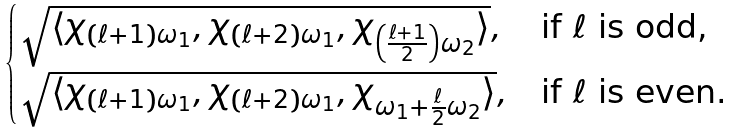<formula> <loc_0><loc_0><loc_500><loc_500>\begin{cases} \sqrt { \langle \chi _ { ( \ell + 1 ) \omega _ { 1 } } , \chi _ { ( \ell + 2 ) \omega _ { 1 } } , \chi _ { \left ( \frac { \ell + 1 } { 2 } \right ) \omega _ { 2 } } \rangle } , & \text {if $\ell$ is odd,} \\ \sqrt { \langle \chi _ { ( \ell + 1 ) \omega _ { 1 } } , \chi _ { ( \ell + 2 ) \omega _ { 1 } } , \chi _ { \omega _ { 1 } + \frac { \ell } { 2 } \omega _ { 2 } } \rangle } , & \text {if $\ell$ is even.} \\ \end{cases}</formula> 